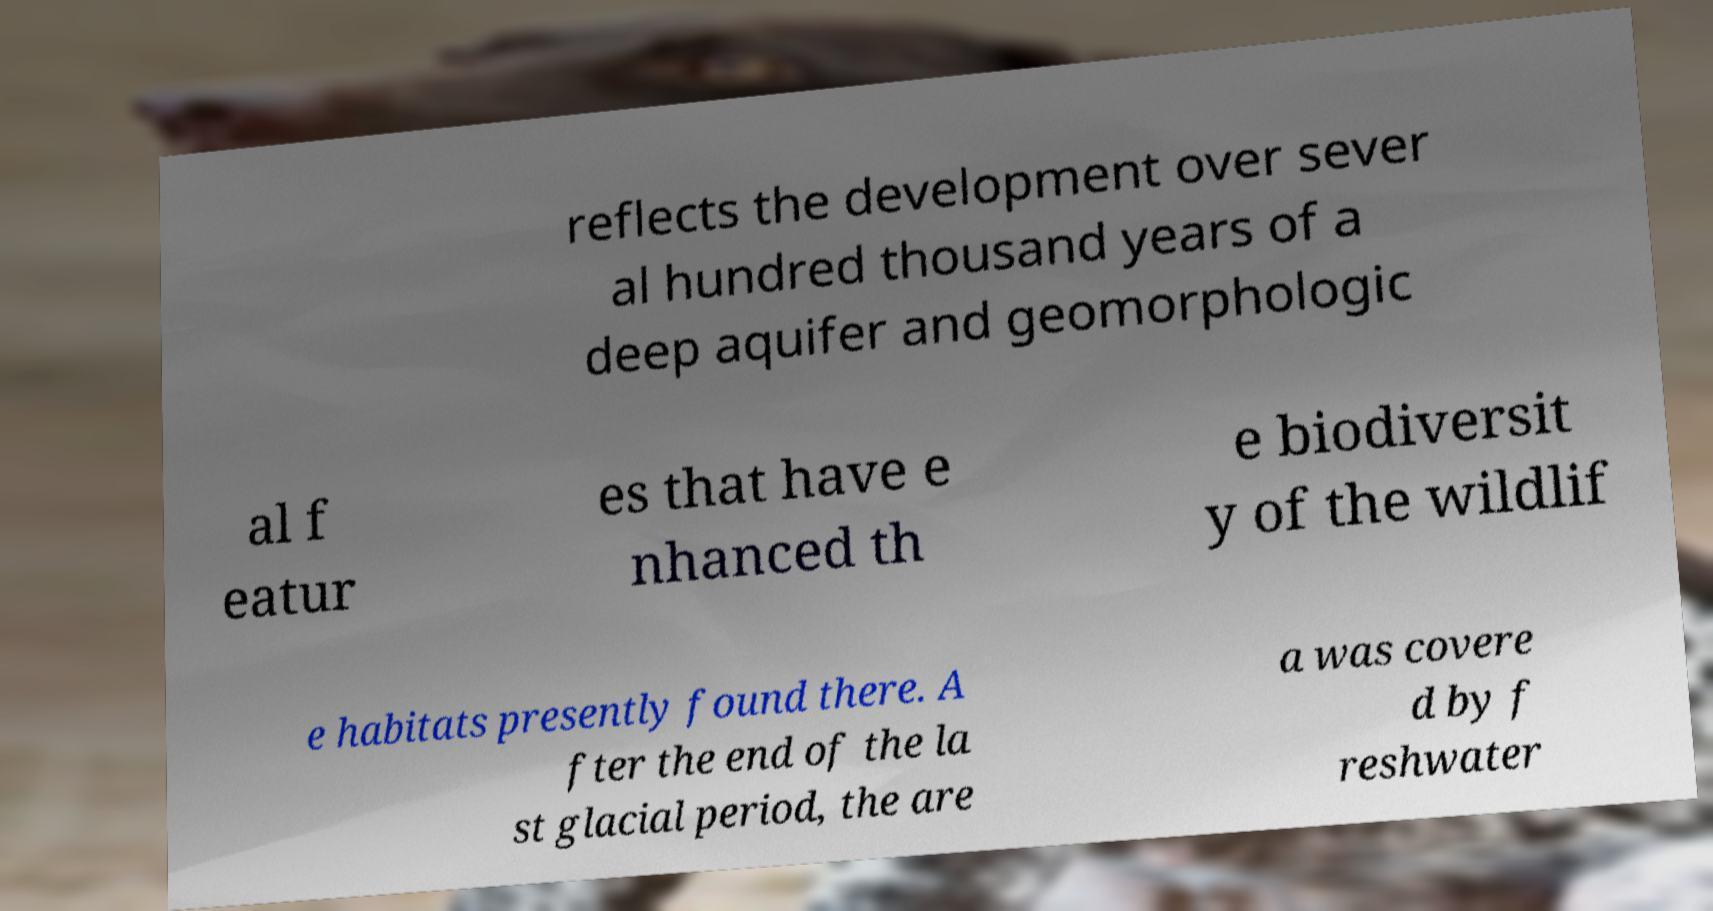Please identify and transcribe the text found in this image. reflects the development over sever al hundred thousand years of a deep aquifer and geomorphologic al f eatur es that have e nhanced th e biodiversit y of the wildlif e habitats presently found there. A fter the end of the la st glacial period, the are a was covere d by f reshwater 